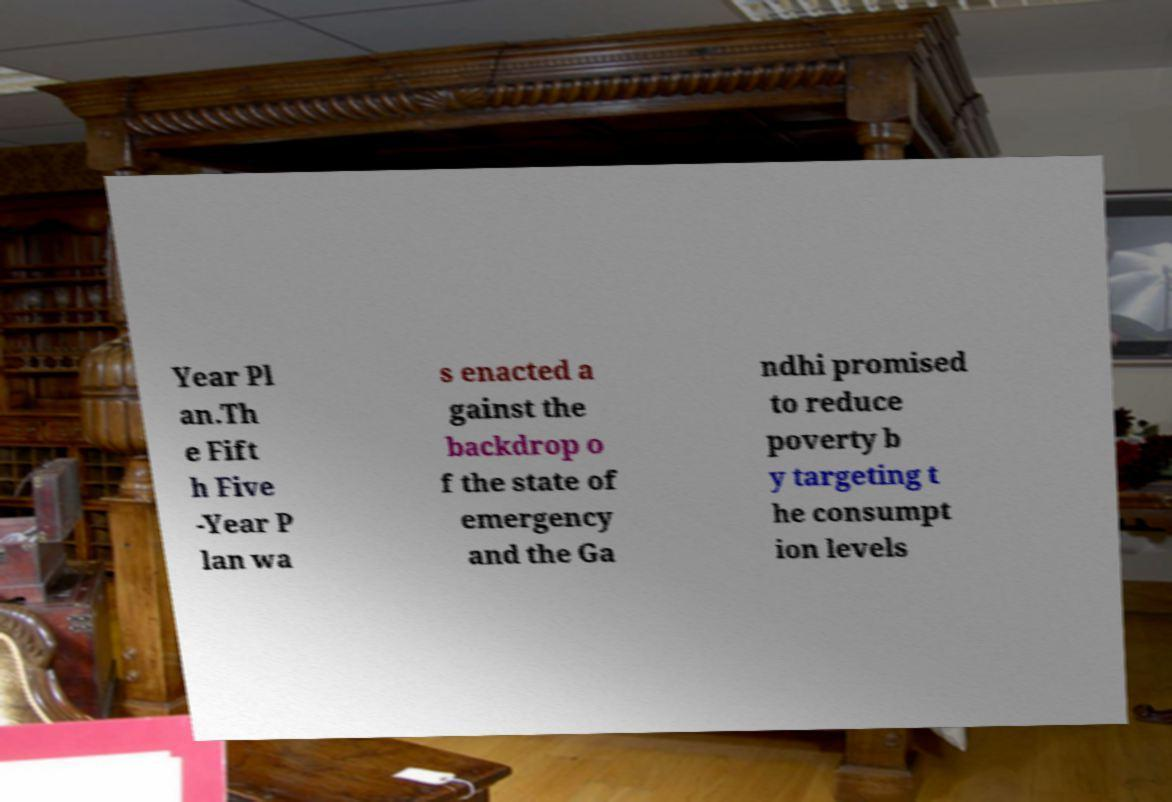Please identify and transcribe the text found in this image. Year Pl an.Th e Fift h Five -Year P lan wa s enacted a gainst the backdrop o f the state of emergency and the Ga ndhi promised to reduce poverty b y targeting t he consumpt ion levels 